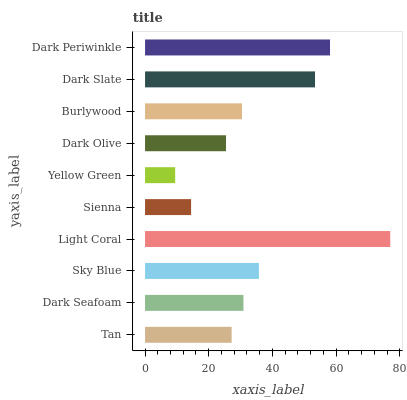Is Yellow Green the minimum?
Answer yes or no. Yes. Is Light Coral the maximum?
Answer yes or no. Yes. Is Dark Seafoam the minimum?
Answer yes or no. No. Is Dark Seafoam the maximum?
Answer yes or no. No. Is Dark Seafoam greater than Tan?
Answer yes or no. Yes. Is Tan less than Dark Seafoam?
Answer yes or no. Yes. Is Tan greater than Dark Seafoam?
Answer yes or no. No. Is Dark Seafoam less than Tan?
Answer yes or no. No. Is Dark Seafoam the high median?
Answer yes or no. Yes. Is Burlywood the low median?
Answer yes or no. Yes. Is Dark Periwinkle the high median?
Answer yes or no. No. Is Sky Blue the low median?
Answer yes or no. No. 